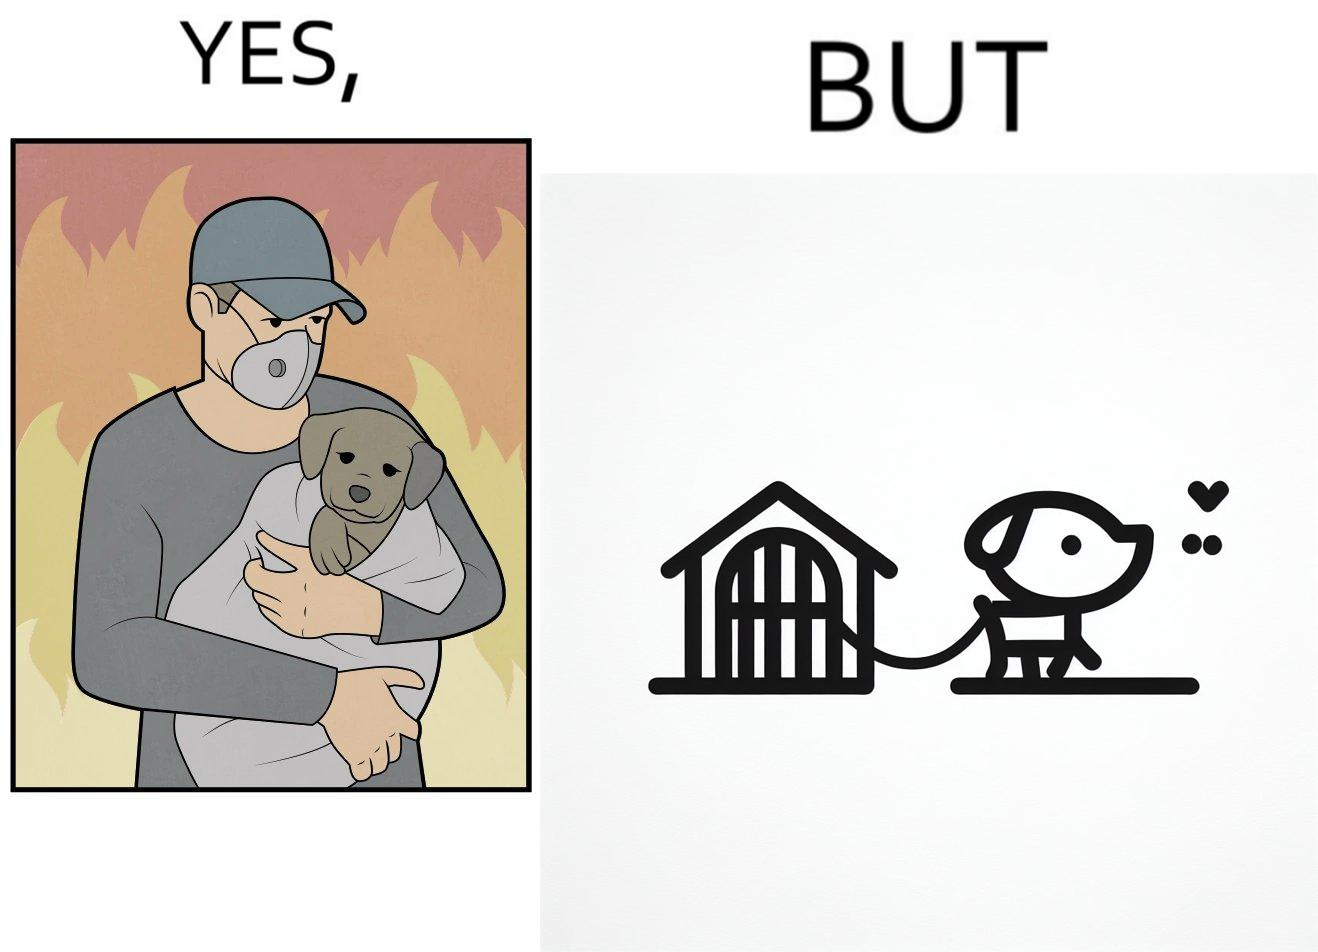What makes this image funny or satirical? The image is ironic, because in the left image the man is showing love and care for the puppy but in the right image the same puppy is shown to be chained in a kennel, which shows dual nature of human towards animals 